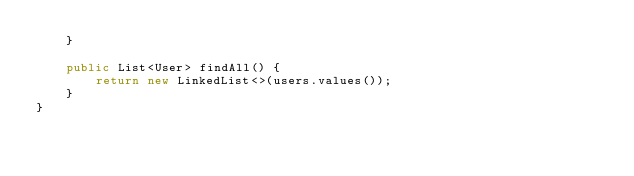<code> <loc_0><loc_0><loc_500><loc_500><_Java_>    }

    public List<User> findAll() {
        return new LinkedList<>(users.values());
    }
}
</code> 